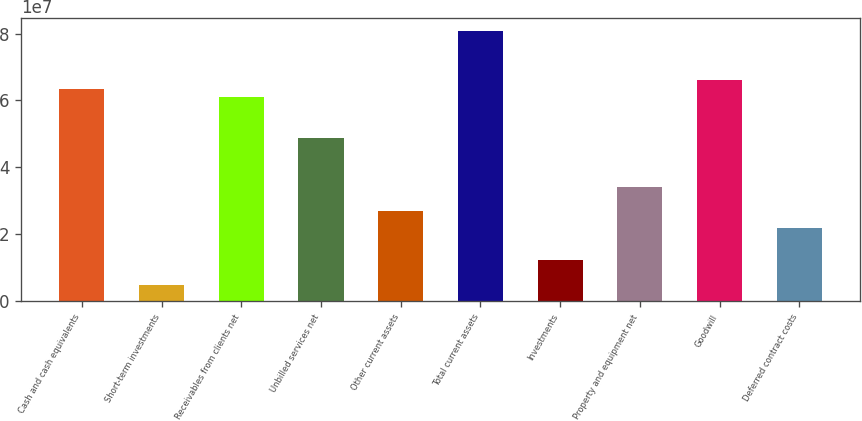Convert chart to OTSL. <chart><loc_0><loc_0><loc_500><loc_500><bar_chart><fcel>Cash and cash equivalents<fcel>Short-term investments<fcel>Receivables from clients net<fcel>Unbilled services net<fcel>Other current assets<fcel>Total current assets<fcel>Investments<fcel>Property and equipment net<fcel>Goodwill<fcel>Deferred contract costs<nl><fcel>6.35676e+07<fcel>4.88983e+06<fcel>6.11227e+07<fcel>4.88982e+07<fcel>2.6894e+07<fcel>8.06819e+07<fcel>1.22245e+07<fcel>3.42287e+07<fcel>6.60125e+07<fcel>2.20042e+07<nl></chart> 